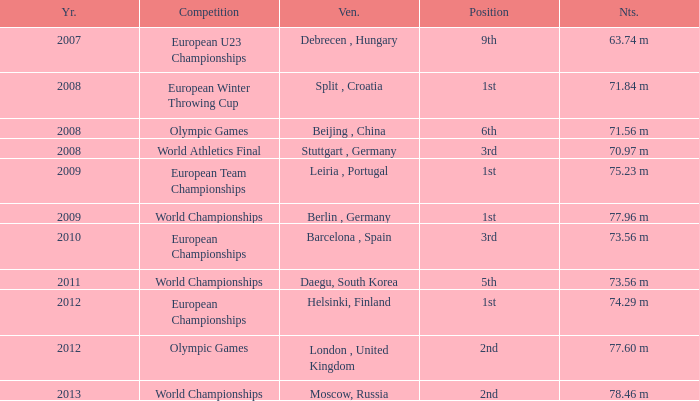What was the venue after 2012? Moscow, Russia. 